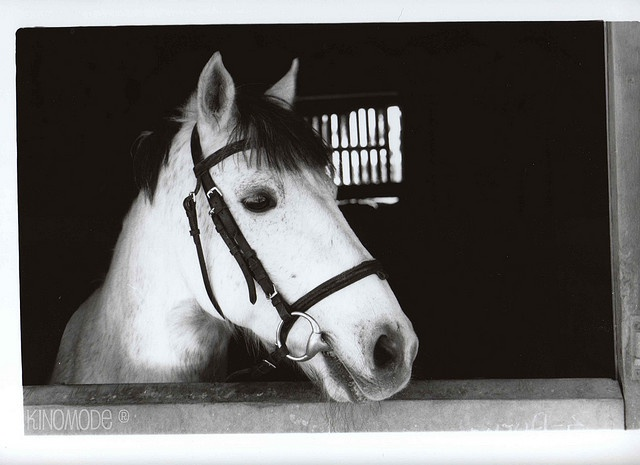Describe the objects in this image and their specific colors. I can see a horse in white, lightgray, black, darkgray, and gray tones in this image. 